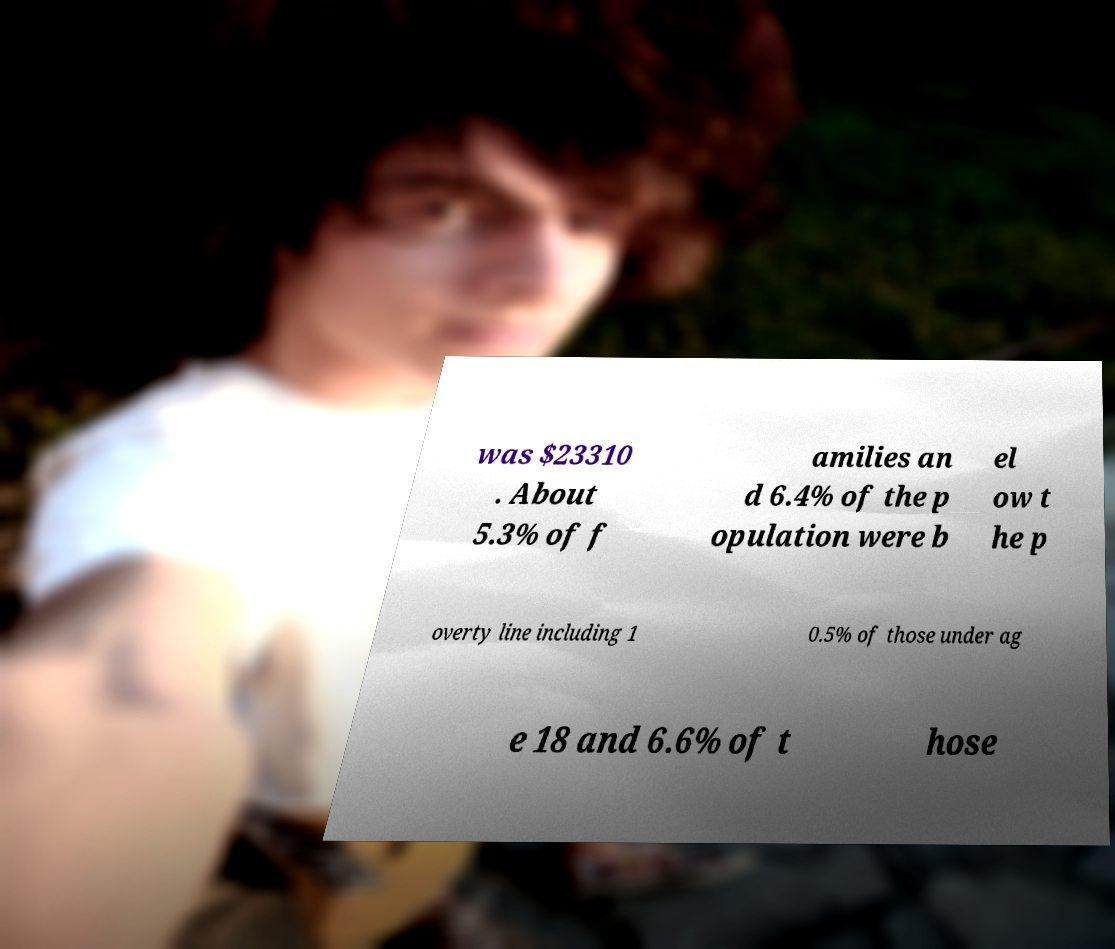Could you extract and type out the text from this image? was $23310 . About 5.3% of f amilies an d 6.4% of the p opulation were b el ow t he p overty line including 1 0.5% of those under ag e 18 and 6.6% of t hose 